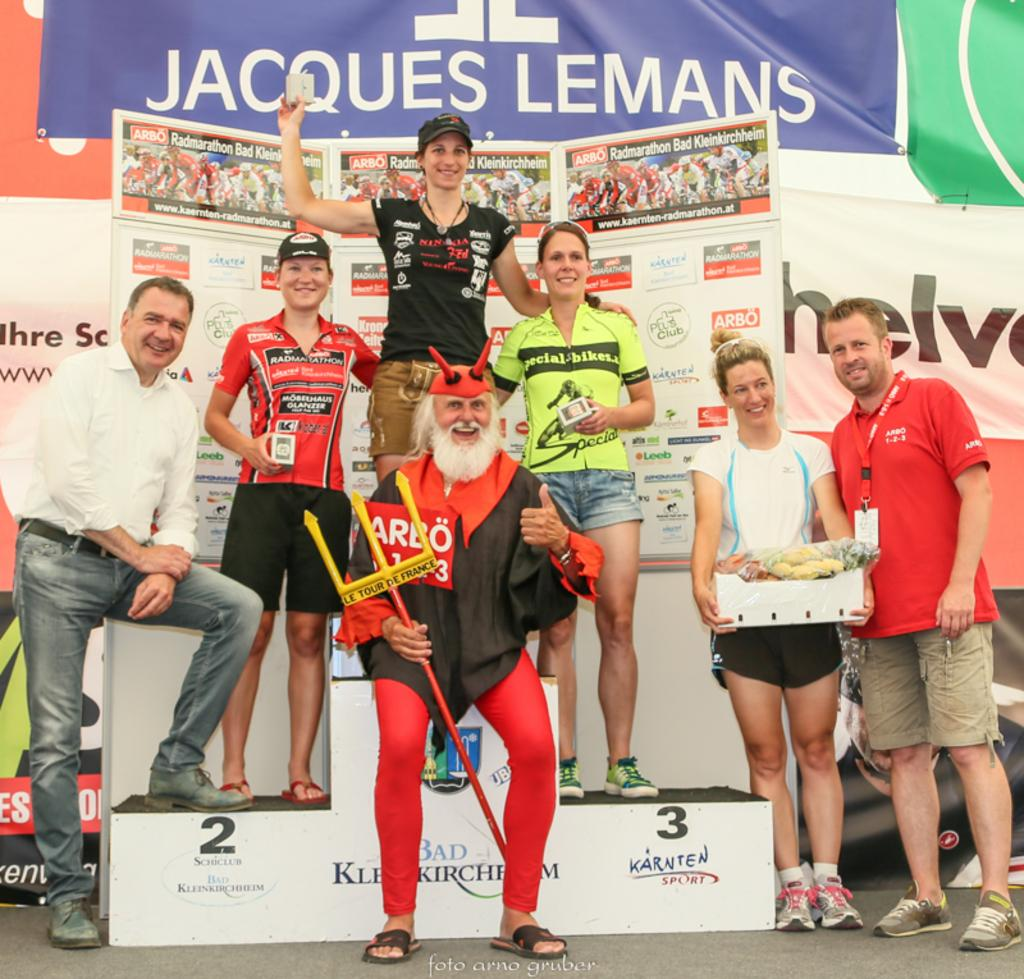Provide a one-sentence caption for the provided image. A group of people posing for a picture with a banner for Jacques Lemans in the background. 